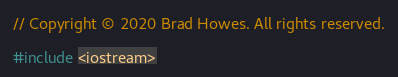<code> <loc_0><loc_0><loc_500><loc_500><_ObjectiveC_>// Copyright © 2020 Brad Howes. All rights reserved.

#include <iostream>
</code> 